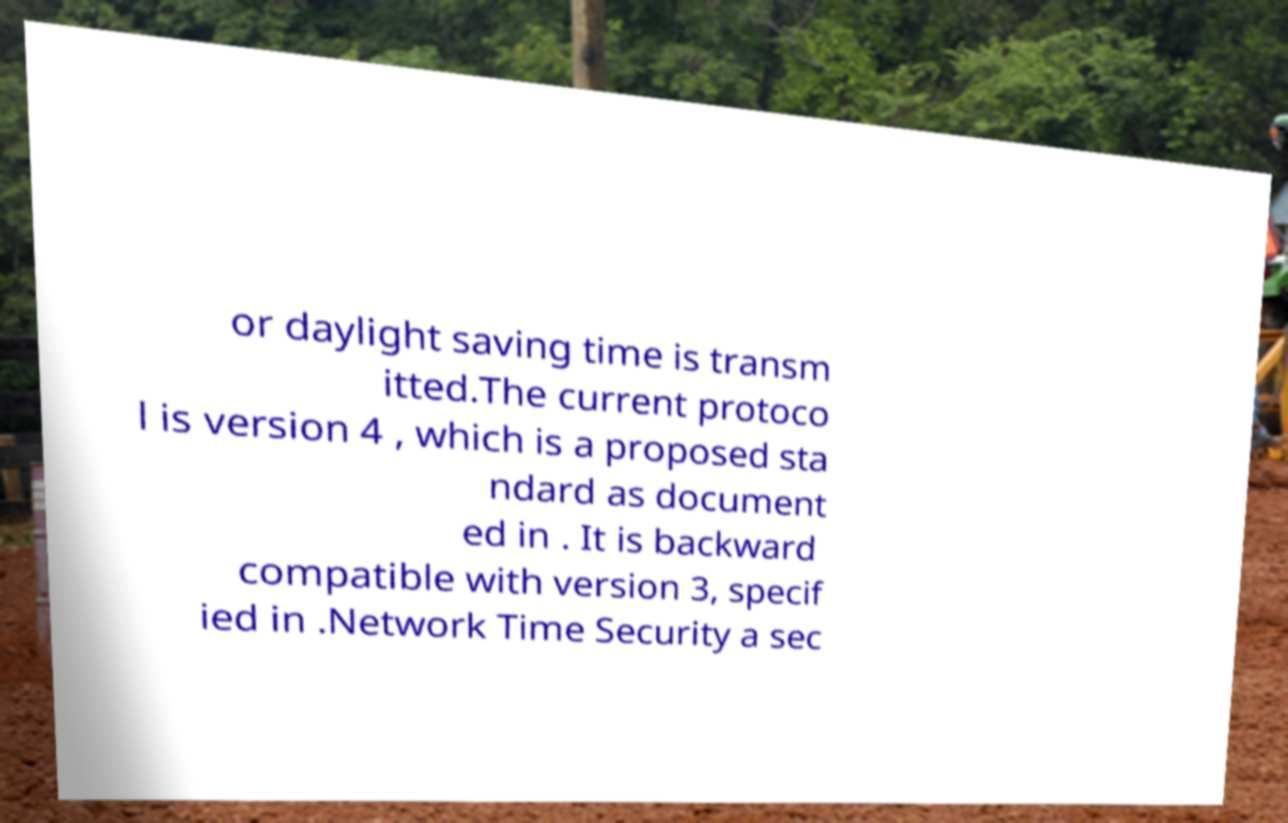What messages or text are displayed in this image? I need them in a readable, typed format. or daylight saving time is transm itted.The current protoco l is version 4 , which is a proposed sta ndard as document ed in . It is backward compatible with version 3, specif ied in .Network Time Security a sec 